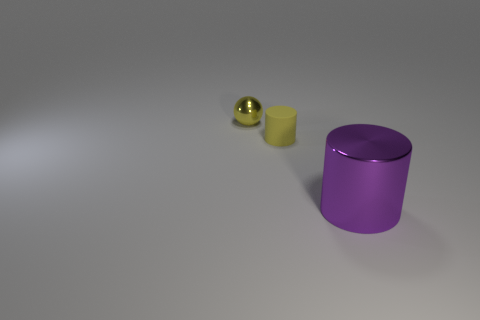Is there any other thing that is the same size as the purple object?
Give a very brief answer. No. The purple thing that is the same shape as the tiny yellow rubber thing is what size?
Offer a very short reply. Large. Are any small rubber things visible?
Make the answer very short. Yes. How many objects are objects in front of the sphere or small red shiny spheres?
Your answer should be very brief. 2. There is a yellow thing that is the same size as the metallic sphere; what is its material?
Give a very brief answer. Rubber. What is the color of the shiny thing that is on the right side of the metal thing that is behind the big purple metal cylinder?
Make the answer very short. Purple. What number of spheres are behind the big purple object?
Your answer should be very brief. 1. What is the color of the sphere?
Your answer should be compact. Yellow. What number of large objects are either shiny things or metallic cubes?
Provide a succinct answer. 1. Is the color of the shiny object behind the small rubber cylinder the same as the metallic thing that is right of the metal ball?
Provide a succinct answer. No. 